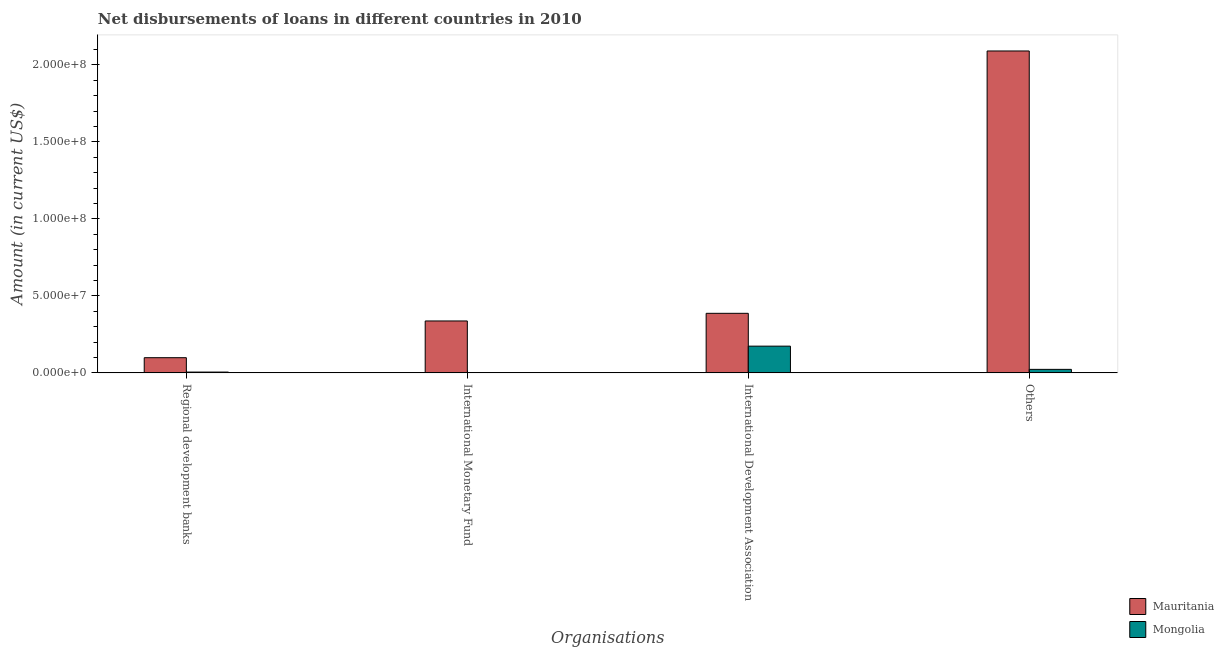How many different coloured bars are there?
Offer a terse response. 2. How many bars are there on the 3rd tick from the left?
Provide a succinct answer. 2. How many bars are there on the 2nd tick from the right?
Give a very brief answer. 2. What is the label of the 1st group of bars from the left?
Give a very brief answer. Regional development banks. What is the amount of loan disimbursed by regional development banks in Mauritania?
Offer a very short reply. 9.85e+06. Across all countries, what is the maximum amount of loan disimbursed by international development association?
Provide a short and direct response. 3.87e+07. Across all countries, what is the minimum amount of loan disimbursed by regional development banks?
Give a very brief answer. 5.20e+05. In which country was the amount of loan disimbursed by regional development banks maximum?
Ensure brevity in your answer.  Mauritania. What is the total amount of loan disimbursed by regional development banks in the graph?
Your answer should be compact. 1.04e+07. What is the difference between the amount of loan disimbursed by international development association in Mauritania and that in Mongolia?
Make the answer very short. 2.13e+07. What is the difference between the amount of loan disimbursed by international development association in Mongolia and the amount of loan disimbursed by regional development banks in Mauritania?
Offer a terse response. 7.49e+06. What is the average amount of loan disimbursed by international monetary fund per country?
Provide a short and direct response. 1.68e+07. What is the difference between the amount of loan disimbursed by regional development banks and amount of loan disimbursed by international monetary fund in Mauritania?
Keep it short and to the point. -2.38e+07. In how many countries, is the amount of loan disimbursed by regional development banks greater than 70000000 US$?
Provide a succinct answer. 0. What is the ratio of the amount of loan disimbursed by other organisations in Mauritania to that in Mongolia?
Keep it short and to the point. 92.14. Is the amount of loan disimbursed by international development association in Mauritania less than that in Mongolia?
Your response must be concise. No. Is the difference between the amount of loan disimbursed by international development association in Mauritania and Mongolia greater than the difference between the amount of loan disimbursed by other organisations in Mauritania and Mongolia?
Your answer should be very brief. No. What is the difference between the highest and the second highest amount of loan disimbursed by other organisations?
Your answer should be very brief. 2.07e+08. What is the difference between the highest and the lowest amount of loan disimbursed by international development association?
Provide a succinct answer. 2.13e+07. In how many countries, is the amount of loan disimbursed by international monetary fund greater than the average amount of loan disimbursed by international monetary fund taken over all countries?
Offer a very short reply. 1. Is the sum of the amount of loan disimbursed by international development association in Mongolia and Mauritania greater than the maximum amount of loan disimbursed by other organisations across all countries?
Ensure brevity in your answer.  No. How many countries are there in the graph?
Give a very brief answer. 2. What is the difference between two consecutive major ticks on the Y-axis?
Ensure brevity in your answer.  5.00e+07. Are the values on the major ticks of Y-axis written in scientific E-notation?
Provide a short and direct response. Yes. Does the graph contain any zero values?
Offer a very short reply. Yes. Does the graph contain grids?
Your answer should be very brief. No. Where does the legend appear in the graph?
Provide a short and direct response. Bottom right. What is the title of the graph?
Ensure brevity in your answer.  Net disbursements of loans in different countries in 2010. What is the label or title of the X-axis?
Offer a terse response. Organisations. What is the label or title of the Y-axis?
Offer a very short reply. Amount (in current US$). What is the Amount (in current US$) of Mauritania in Regional development banks?
Ensure brevity in your answer.  9.85e+06. What is the Amount (in current US$) in Mongolia in Regional development banks?
Give a very brief answer. 5.20e+05. What is the Amount (in current US$) of Mauritania in International Monetary Fund?
Provide a succinct answer. 3.37e+07. What is the Amount (in current US$) of Mongolia in International Monetary Fund?
Offer a terse response. 0. What is the Amount (in current US$) of Mauritania in International Development Association?
Your answer should be compact. 3.87e+07. What is the Amount (in current US$) in Mongolia in International Development Association?
Make the answer very short. 1.73e+07. What is the Amount (in current US$) of Mauritania in Others?
Your answer should be compact. 2.09e+08. What is the Amount (in current US$) in Mongolia in Others?
Your answer should be very brief. 2.27e+06. Across all Organisations, what is the maximum Amount (in current US$) in Mauritania?
Your answer should be compact. 2.09e+08. Across all Organisations, what is the maximum Amount (in current US$) in Mongolia?
Keep it short and to the point. 1.73e+07. Across all Organisations, what is the minimum Amount (in current US$) in Mauritania?
Ensure brevity in your answer.  9.85e+06. Across all Organisations, what is the minimum Amount (in current US$) of Mongolia?
Your answer should be very brief. 0. What is the total Amount (in current US$) of Mauritania in the graph?
Offer a terse response. 2.91e+08. What is the total Amount (in current US$) in Mongolia in the graph?
Ensure brevity in your answer.  2.01e+07. What is the difference between the Amount (in current US$) of Mauritania in Regional development banks and that in International Monetary Fund?
Provide a short and direct response. -2.38e+07. What is the difference between the Amount (in current US$) in Mauritania in Regional development banks and that in International Development Association?
Give a very brief answer. -2.88e+07. What is the difference between the Amount (in current US$) in Mongolia in Regional development banks and that in International Development Association?
Provide a short and direct response. -1.68e+07. What is the difference between the Amount (in current US$) of Mauritania in Regional development banks and that in Others?
Provide a short and direct response. -1.99e+08. What is the difference between the Amount (in current US$) in Mongolia in Regional development banks and that in Others?
Provide a short and direct response. -1.75e+06. What is the difference between the Amount (in current US$) in Mauritania in International Monetary Fund and that in International Development Association?
Make the answer very short. -4.96e+06. What is the difference between the Amount (in current US$) in Mauritania in International Monetary Fund and that in Others?
Provide a succinct answer. -1.75e+08. What is the difference between the Amount (in current US$) in Mauritania in International Development Association and that in Others?
Your response must be concise. -1.70e+08. What is the difference between the Amount (in current US$) of Mongolia in International Development Association and that in Others?
Provide a short and direct response. 1.51e+07. What is the difference between the Amount (in current US$) of Mauritania in Regional development banks and the Amount (in current US$) of Mongolia in International Development Association?
Offer a very short reply. -7.49e+06. What is the difference between the Amount (in current US$) of Mauritania in Regional development banks and the Amount (in current US$) of Mongolia in Others?
Your answer should be compact. 7.58e+06. What is the difference between the Amount (in current US$) in Mauritania in International Monetary Fund and the Amount (in current US$) in Mongolia in International Development Association?
Keep it short and to the point. 1.64e+07. What is the difference between the Amount (in current US$) of Mauritania in International Monetary Fund and the Amount (in current US$) of Mongolia in Others?
Offer a very short reply. 3.14e+07. What is the difference between the Amount (in current US$) of Mauritania in International Development Association and the Amount (in current US$) of Mongolia in Others?
Offer a terse response. 3.64e+07. What is the average Amount (in current US$) of Mauritania per Organisations?
Keep it short and to the point. 7.28e+07. What is the average Amount (in current US$) of Mongolia per Organisations?
Provide a succinct answer. 5.03e+06. What is the difference between the Amount (in current US$) of Mauritania and Amount (in current US$) of Mongolia in Regional development banks?
Provide a succinct answer. 9.33e+06. What is the difference between the Amount (in current US$) of Mauritania and Amount (in current US$) of Mongolia in International Development Association?
Ensure brevity in your answer.  2.13e+07. What is the difference between the Amount (in current US$) of Mauritania and Amount (in current US$) of Mongolia in Others?
Offer a very short reply. 2.07e+08. What is the ratio of the Amount (in current US$) of Mauritania in Regional development banks to that in International Monetary Fund?
Provide a short and direct response. 0.29. What is the ratio of the Amount (in current US$) of Mauritania in Regional development banks to that in International Development Association?
Make the answer very short. 0.25. What is the ratio of the Amount (in current US$) of Mongolia in Regional development banks to that in International Development Association?
Your answer should be compact. 0.03. What is the ratio of the Amount (in current US$) in Mauritania in Regional development banks to that in Others?
Provide a short and direct response. 0.05. What is the ratio of the Amount (in current US$) of Mongolia in Regional development banks to that in Others?
Provide a short and direct response. 0.23. What is the ratio of the Amount (in current US$) of Mauritania in International Monetary Fund to that in International Development Association?
Ensure brevity in your answer.  0.87. What is the ratio of the Amount (in current US$) in Mauritania in International Monetary Fund to that in Others?
Provide a succinct answer. 0.16. What is the ratio of the Amount (in current US$) of Mauritania in International Development Association to that in Others?
Provide a succinct answer. 0.18. What is the ratio of the Amount (in current US$) in Mongolia in International Development Association to that in Others?
Give a very brief answer. 7.65. What is the difference between the highest and the second highest Amount (in current US$) in Mauritania?
Offer a terse response. 1.70e+08. What is the difference between the highest and the second highest Amount (in current US$) in Mongolia?
Ensure brevity in your answer.  1.51e+07. What is the difference between the highest and the lowest Amount (in current US$) in Mauritania?
Ensure brevity in your answer.  1.99e+08. What is the difference between the highest and the lowest Amount (in current US$) in Mongolia?
Ensure brevity in your answer.  1.73e+07. 